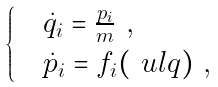Convert formula to latex. <formula><loc_0><loc_0><loc_500><loc_500>\begin{cases} & \dot { q } _ { i } = \frac { p _ { i } } { m } \ , \\ & \dot { p } _ { i } = f _ { i } ( \ u l q ) \ , \end{cases}</formula> 